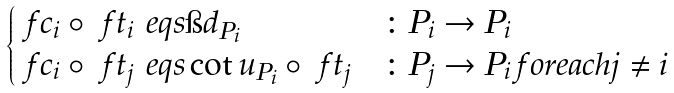Convert formula to latex. <formula><loc_0><loc_0><loc_500><loc_500>\begin{cases} \ f c _ { i } \circ \ f t _ { i } \ e q s \i d _ { P _ { i } } & \colon P _ { i } \to P _ { i } \\ \ f c _ { i } \circ \ f t _ { j } \ e q s \cot u _ { P _ { i } } \circ \ f t _ { j } & \colon P _ { j } \to P _ { i } \, f o r e a c h j \ne i \\ \end{cases}</formula> 